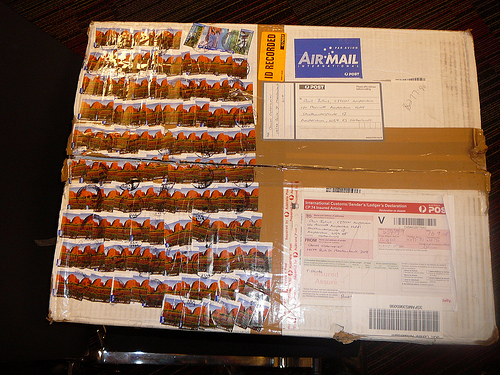<image>
Can you confirm if the stamp is above the tape? No. The stamp is not positioned above the tape. The vertical arrangement shows a different relationship. 